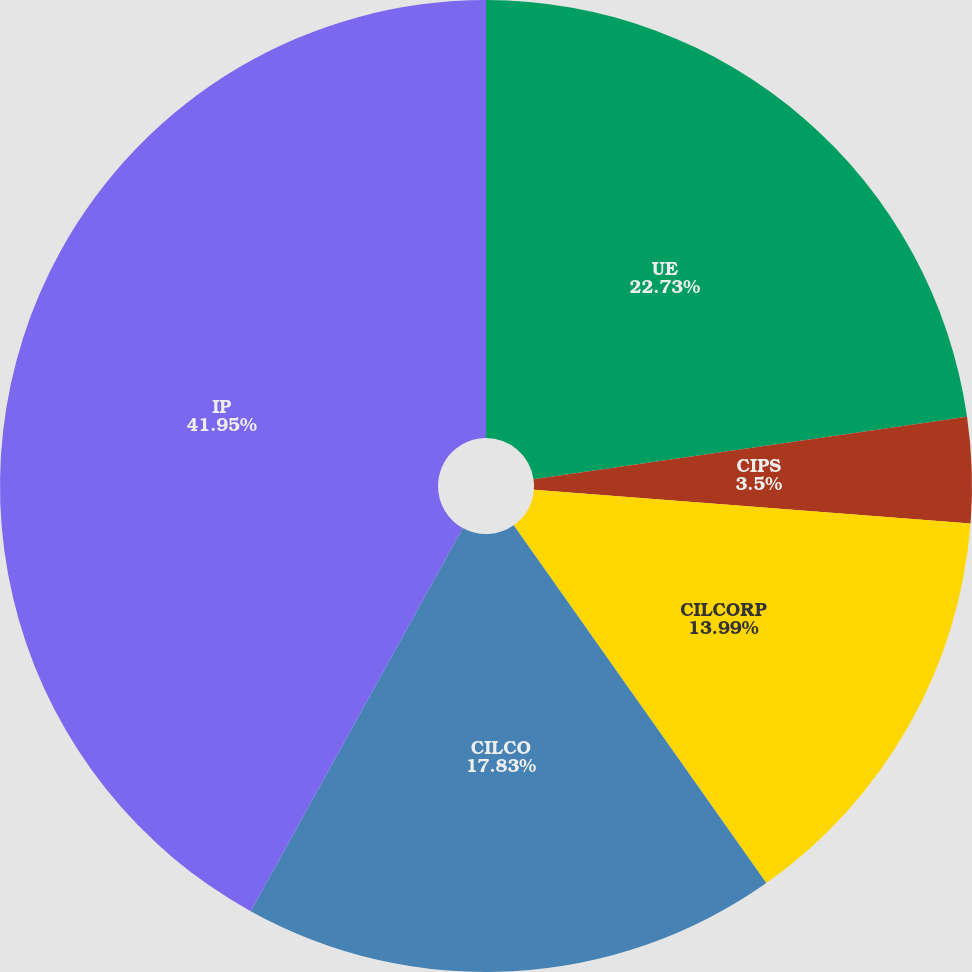Convert chart. <chart><loc_0><loc_0><loc_500><loc_500><pie_chart><fcel>UE<fcel>CIPS<fcel>CILCORP<fcel>CILCO<fcel>IP<nl><fcel>22.73%<fcel>3.5%<fcel>13.99%<fcel>17.83%<fcel>41.96%<nl></chart> 